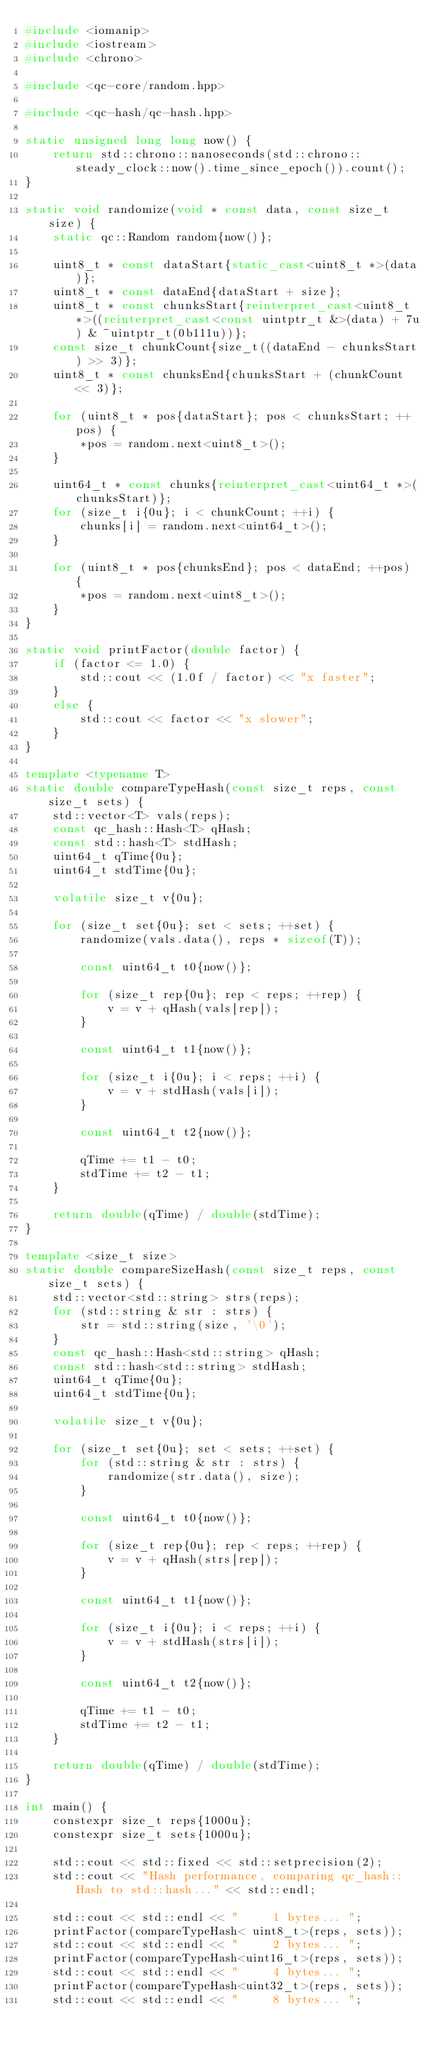Convert code to text. <code><loc_0><loc_0><loc_500><loc_500><_C++_>#include <iomanip>
#include <iostream>
#include <chrono>

#include <qc-core/random.hpp>

#include <qc-hash/qc-hash.hpp>

static unsigned long long now() {
    return std::chrono::nanoseconds(std::chrono::steady_clock::now().time_since_epoch()).count();
}

static void randomize(void * const data, const size_t size) {
    static qc::Random random{now()};

    uint8_t * const dataStart{static_cast<uint8_t *>(data)};
    uint8_t * const dataEnd{dataStart + size};
    uint8_t * const chunksStart{reinterpret_cast<uint8_t *>((reinterpret_cast<const uintptr_t &>(data) + 7u) & ~uintptr_t(0b111u))};
    const size_t chunkCount{size_t((dataEnd - chunksStart) >> 3)};
    uint8_t * const chunksEnd{chunksStart + (chunkCount << 3)};

    for (uint8_t * pos{dataStart}; pos < chunksStart; ++pos) {
        *pos = random.next<uint8_t>();
    }

    uint64_t * const chunks{reinterpret_cast<uint64_t *>(chunksStart)};
    for (size_t i{0u}; i < chunkCount; ++i) {
        chunks[i] = random.next<uint64_t>();
    }

    for (uint8_t * pos{chunksEnd}; pos < dataEnd; ++pos) {
        *pos = random.next<uint8_t>();
    }
}

static void printFactor(double factor) {
    if (factor <= 1.0) {
        std::cout << (1.0f / factor) << "x faster";
    }
    else {
        std::cout << factor << "x slower";
    }
}

template <typename T>
static double compareTypeHash(const size_t reps, const size_t sets) {
    std::vector<T> vals(reps);
    const qc_hash::Hash<T> qHash;
    const std::hash<T> stdHash;
    uint64_t qTime{0u};
    uint64_t stdTime{0u};

    volatile size_t v{0u};

    for (size_t set{0u}; set < sets; ++set) {
        randomize(vals.data(), reps * sizeof(T));

        const uint64_t t0{now()};

        for (size_t rep{0u}; rep < reps; ++rep) {
            v = v + qHash(vals[rep]);
        }

        const uint64_t t1{now()};

        for (size_t i{0u}; i < reps; ++i) {
            v = v + stdHash(vals[i]);
        }

        const uint64_t t2{now()};

        qTime += t1 - t0;
        stdTime += t2 - t1;
    }

    return double(qTime) / double(stdTime);
}

template <size_t size>
static double compareSizeHash(const size_t reps, const size_t sets) {
    std::vector<std::string> strs(reps);
    for (std::string & str : strs) {
        str = std::string(size, '\0');
    }
    const qc_hash::Hash<std::string> qHash;
    const std::hash<std::string> stdHash;
    uint64_t qTime{0u};
    uint64_t stdTime{0u};

    volatile size_t v{0u};

    for (size_t set{0u}; set < sets; ++set) {
        for (std::string & str : strs) {
            randomize(str.data(), size);
        }

        const uint64_t t0{now()};

        for (size_t rep{0u}; rep < reps; ++rep) {
            v = v + qHash(strs[rep]);
        }

        const uint64_t t1{now()};

        for (size_t i{0u}; i < reps; ++i) {
            v = v + stdHash(strs[i]);
        }

        const uint64_t t2{now()};

        qTime += t1 - t0;
        stdTime += t2 - t1;
    }

    return double(qTime) / double(stdTime);
}

int main() {
    constexpr size_t reps{1000u};
    constexpr size_t sets{1000u};

    std::cout << std::fixed << std::setprecision(2);
    std::cout << "Hash performance, comparing qc_hash::Hash to std::hash..." << std::endl;

    std::cout << std::endl << "     1 bytes... ";
    printFactor(compareTypeHash< uint8_t>(reps, sets));
    std::cout << std::endl << "     2 bytes... ";
    printFactor(compareTypeHash<uint16_t>(reps, sets));
    std::cout << std::endl << "     4 bytes... ";
    printFactor(compareTypeHash<uint32_t>(reps, sets));
    std::cout << std::endl << "     8 bytes... ";</code> 